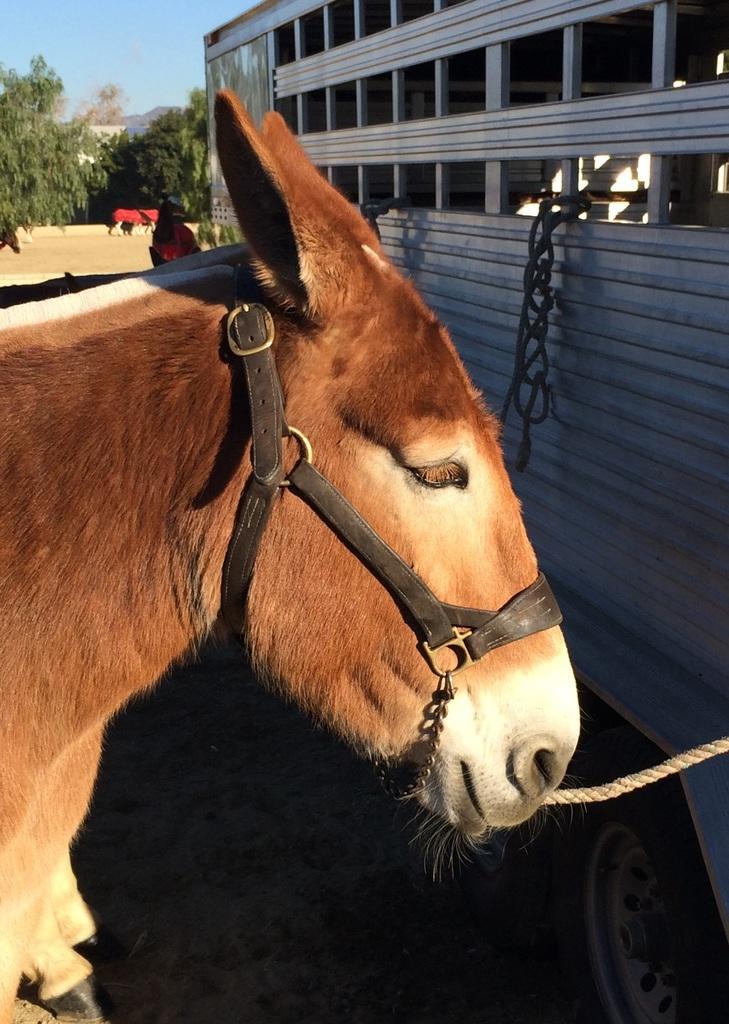Can you describe this image briefly? In this image there is an animal, in front of the animal there is a vehicle. In the background there are few more animals, trees and a sky. 